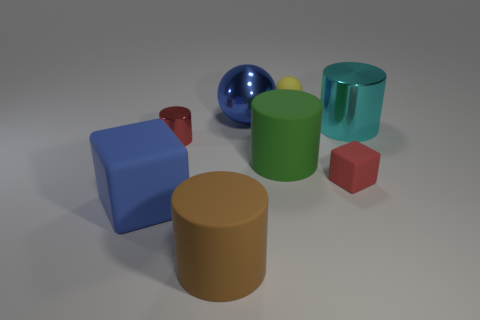Is the number of things left of the large rubber block less than the number of big purple things?
Your answer should be very brief. No. How many metallic objects are large yellow spheres or big things?
Offer a terse response. 2. Is the small block the same color as the metallic ball?
Your answer should be very brief. No. Is there anything else that has the same color as the matte sphere?
Make the answer very short. No. Does the large blue object that is behind the green thing have the same shape as the thing that is on the left side of the red cylinder?
Ensure brevity in your answer.  No. How many objects are either big brown rubber cylinders or cylinders that are in front of the cyan thing?
Offer a terse response. 3. What number of other objects are the same size as the blue block?
Keep it short and to the point. 4. Does the cube that is to the left of the small rubber cube have the same material as the tiny red object that is right of the brown rubber object?
Your answer should be very brief. Yes. What number of matte cylinders are left of the large blue sphere?
Your response must be concise. 1. How many cyan things are either rubber cylinders or large balls?
Give a very brief answer. 0. 